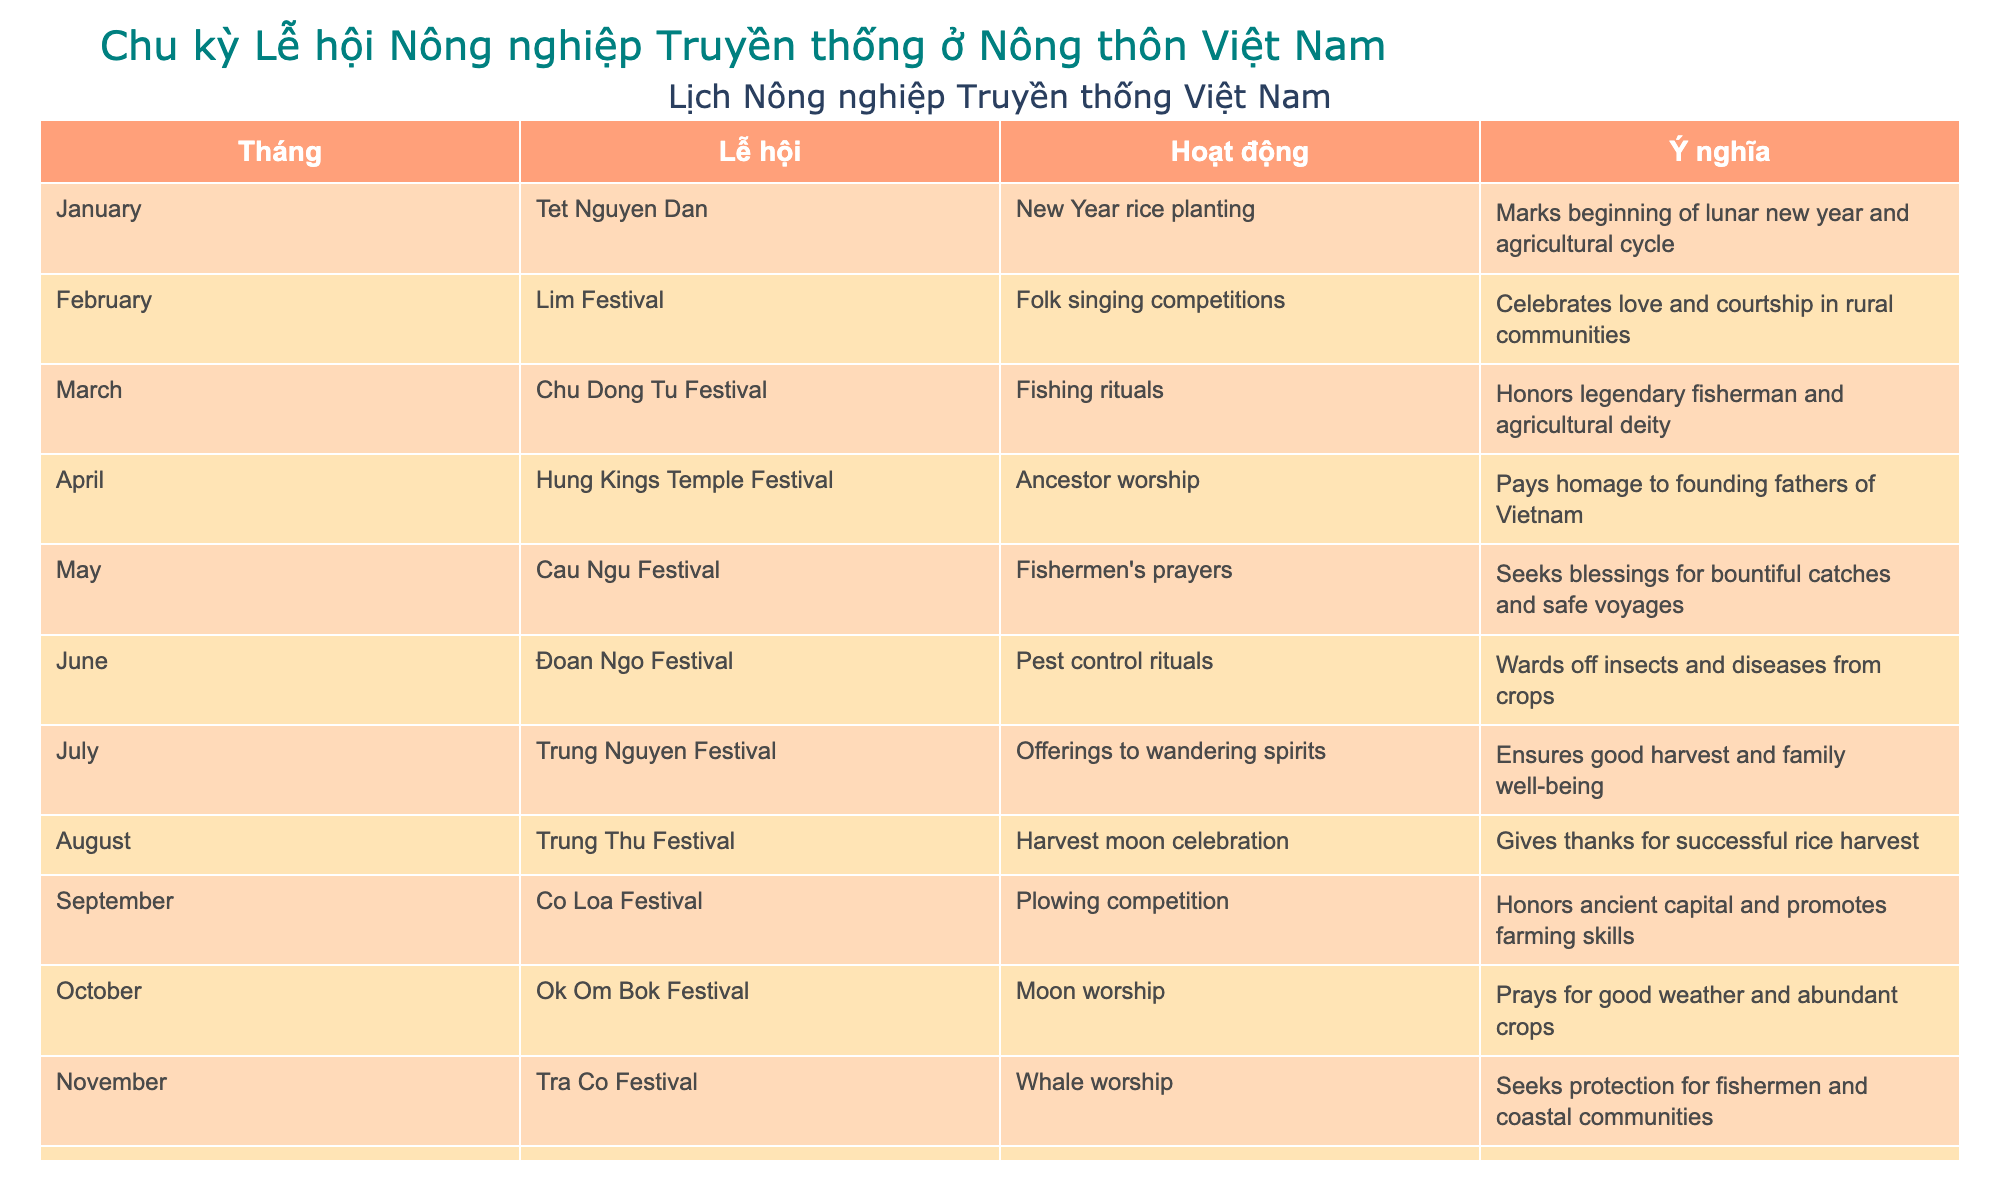What festival takes place in January? According to the table, the festival that takes place in January is "Tet Nguyen Dan."
Answer: Tet Nguyen Dan What is the significance of the Trung Thu Festival in August? The significance of the Trung Thu Festival in August is to give thanks for a successful rice harvest.
Answer: Thanking for successful rice harvest Which month has an activity related to ancestor worship? The month that has an activity related to ancestor worship is April, specifically during the Hung Kings Temple Festival.
Answer: April (Hung Kings Temple Festival) How many festivals in the table are related to fishing? There are three festivals related to fishing: Chu Dong Tu Festival in March, Cau Ngu Festival in May, and Tra Co Festival in November. Therefore, the total count is 3.
Answer: 3 Is the Doan Ngo Festival held in June? Yes, the Doan Ngo Festival, which includes pest control rituals, is indeed held in June.
Answer: Yes Which festival is associated with pest control rituals? The festival associated with pest control rituals is the Doan Ngo Festival, which takes place in June.
Answer: Doan Ngo Festival What activities are held at the Trung Nguyen Festival? The Trung Nguyen Festival, held in July, includes offerings to wandering spirits as its main activity.
Answer: Offerings to wandering spirits Which festival occurs just before the harvest moon celebration? The festival that occurs just before the Trung Thu Festival (harvest moon celebration) in August is Trung Nguyen Festival in July.
Answer: Trung Nguyen Festival In which month do fishermen's prayers take place, and what is their significance? Fishermen’s prayers take place in May during the Cau Ngu Festival, which seeks blessings for bountiful catches and safe voyages.
Answer: May (Cau Ngu Festival) - for bountiful catches and safe voyages 